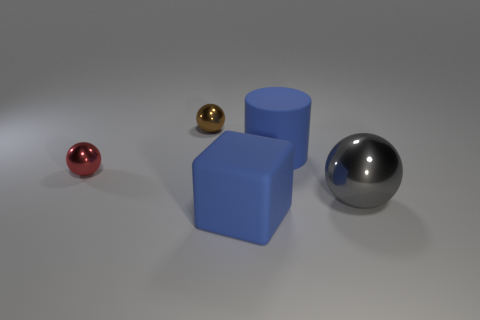Subtract all small balls. How many balls are left? 1 Add 5 large gray cubes. How many objects exist? 10 Subtract all red balls. How many balls are left? 2 Subtract all spheres. How many objects are left? 2 Subtract all gray cylinders. How many brown spheres are left? 1 Subtract all small red shiny spheres. Subtract all big matte cylinders. How many objects are left? 3 Add 4 big gray spheres. How many big gray spheres are left? 5 Add 2 rubber objects. How many rubber objects exist? 4 Subtract 0 cyan cubes. How many objects are left? 5 Subtract 2 balls. How many balls are left? 1 